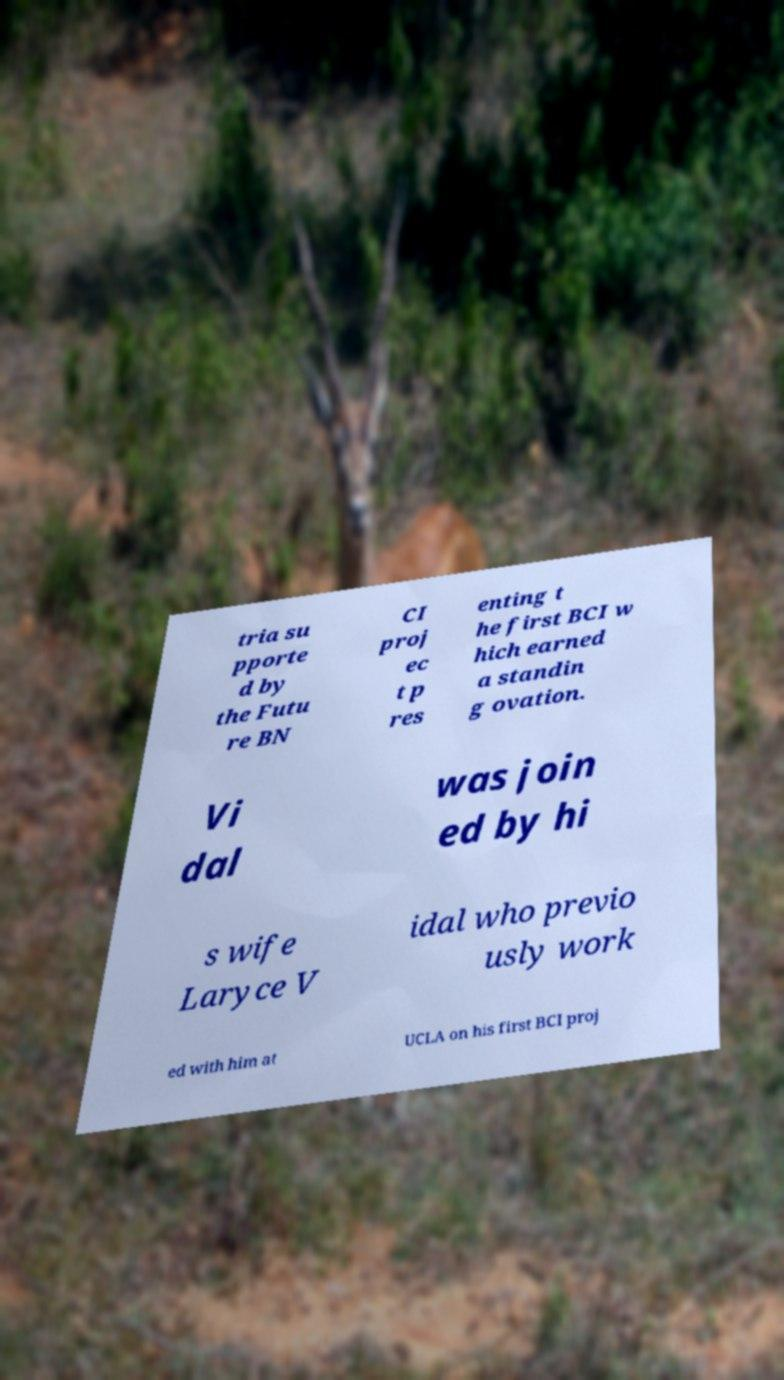Can you read and provide the text displayed in the image?This photo seems to have some interesting text. Can you extract and type it out for me? tria su pporte d by the Futu re BN CI proj ec t p res enting t he first BCI w hich earned a standin g ovation. Vi dal was join ed by hi s wife Laryce V idal who previo usly work ed with him at UCLA on his first BCI proj 